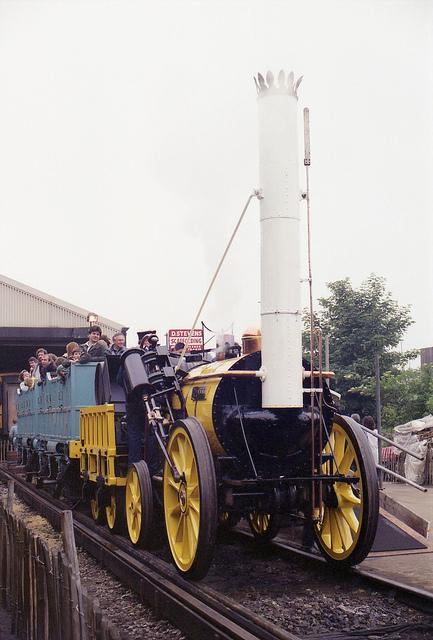Is this a modern train?
Give a very brief answer. No. Is the sky clear?
Concise answer only. No. How many colors is the train?
Give a very brief answer. 4. 